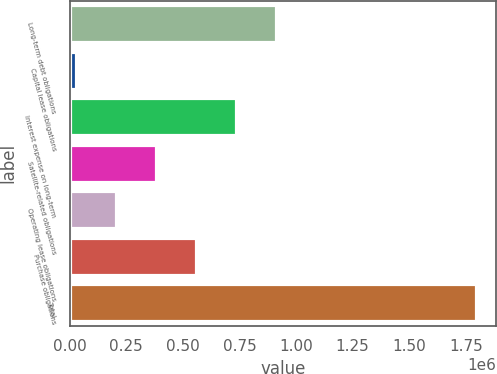<chart> <loc_0><loc_0><loc_500><loc_500><bar_chart><fcel>Long-term debt obligations<fcel>Capital lease obligations<fcel>Interest expense on long-term<fcel>Satellite-related obligations<fcel>Operating lease obligations<fcel>Purchase obligations<fcel>Total<nl><fcel>911590<fcel>27339<fcel>734739<fcel>381039<fcel>204189<fcel>557889<fcel>1.79584e+06<nl></chart> 